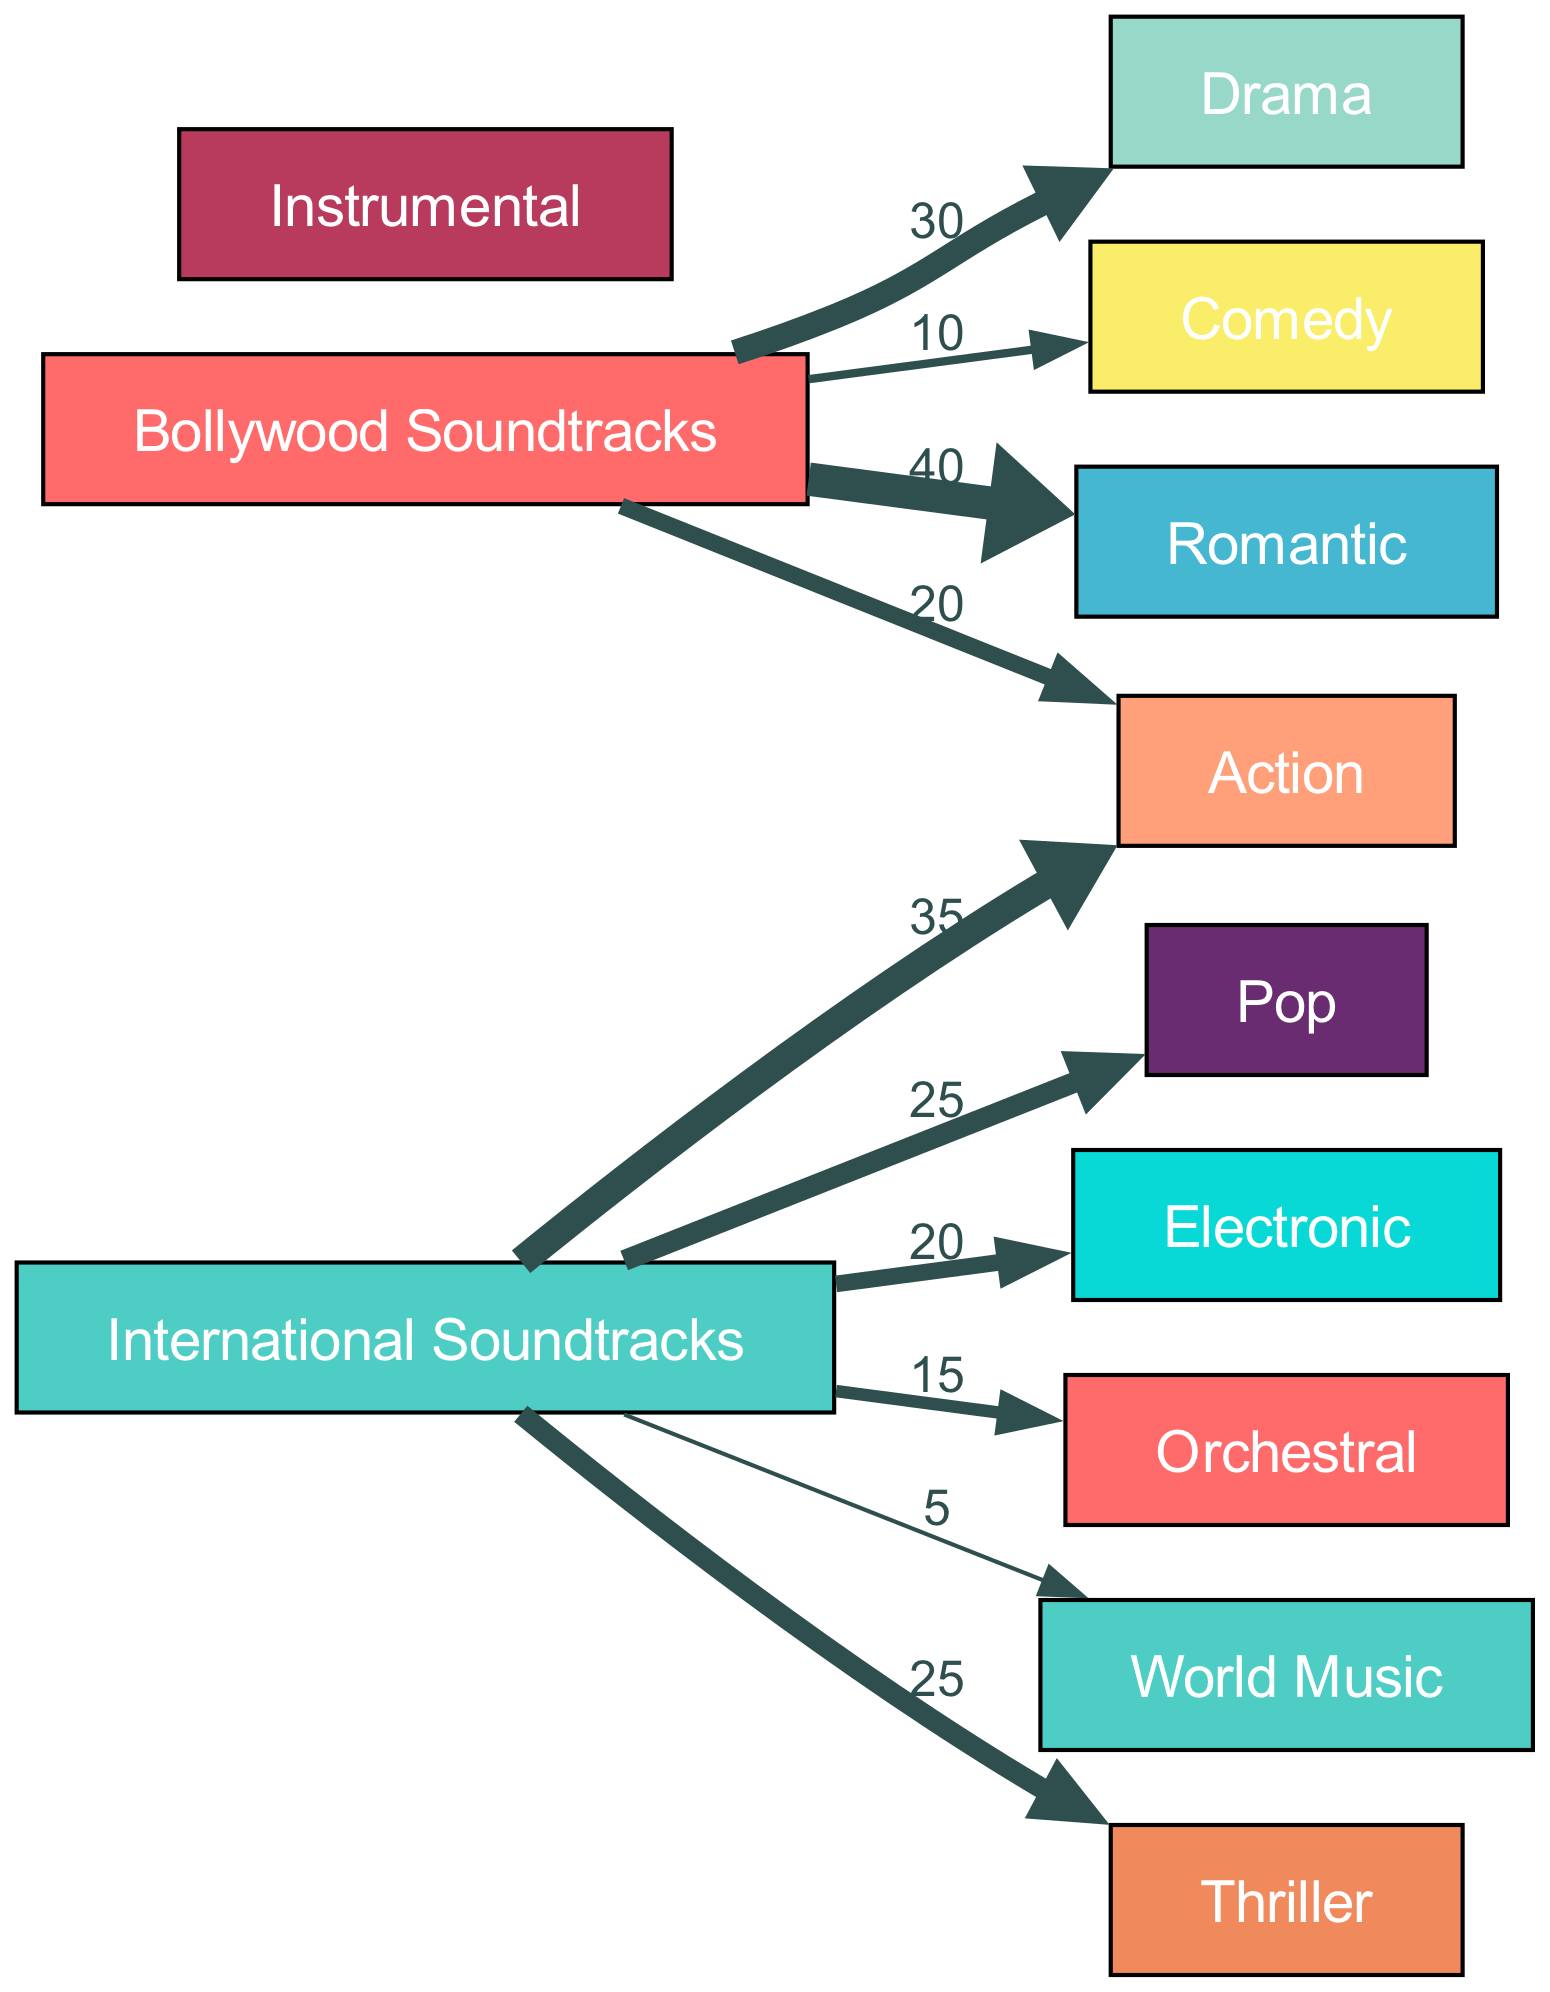What genre has the highest preference in Bollywood soundtracks? The diagram shows that the Romantic genre has a value of 40, which is higher than any other genre connected to Bollywood Soundtracks.
Answer: Romantic What is the value of the Action genre for International Soundtracks? Looking at the link from International Soundtracks to Action, the value is clearly indicated as 35.
Answer: 35 How many genres are there in total for Bollywood soundtracks? By examining the nodes connected to Bollywood Soundtracks, we count six different genres: Romantic, Drama, Action, Comedy, and two more, totaling five.
Answer: 5 Which genre has the lowest preference in International Soundtracks? The link to World Music from International Soundtracks shows the lowest value of 5, indicating it is the least preferred genre.
Answer: World Music What proportion of Bollywood soundtracks are Romantic compared to all genres? The Romantic genre has a value of 40 out of a total of 100 for all Bollywood genres (40 + 30 + 20 + 10 = 100), indicating 40% of preferences are for Romantic soundtracks.
Answer: 40% Which genre has a higher preference: Comedy in Bollywood or Thriller in International? The value for Comedy in Bollywood is 10, while the value for Thriller in International is 25, showing that Thriller has a higher preference than Comedy.
Answer: Thriller How many genres have a preference value greater than 20 in Bollywood soundtracks? The genres with values higher than 20 in Bollywood are Romantic (40), Drama (30), and Action (20), which total three genres.
Answer: 3 What is the total preference value for all genres connected to International Soundtracks? Summing the values for the International Soundtracks genres (35 + 25 + 20 + 15 + 5 + 25) results in a total of 125.
Answer: 125 Which genre has the highest connection value from International Soundtracks? The genre with the highest connection from International Soundtracks is Action, with a value of 35, which is higher than the connections to all other genres.
Answer: Action 